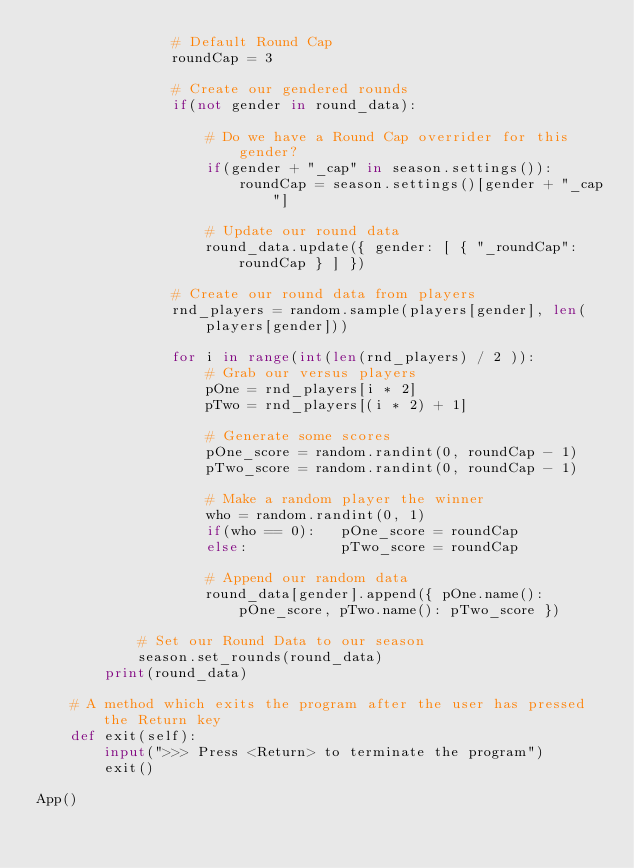<code> <loc_0><loc_0><loc_500><loc_500><_Python_>                # Default Round Cap
                roundCap = 3

                # Create our gendered rounds
                if(not gender in round_data):

                    # Do we have a Round Cap overrider for this gender?
                    if(gender + "_cap" in season.settings()):
                        roundCap = season.settings()[gender + "_cap"]
                    
                    # Update our round data
                    round_data.update({ gender: [ { "_roundCap": roundCap } ] })

                # Create our round data from players
                rnd_players = random.sample(players[gender], len(players[gender]))

                for i in range(int(len(rnd_players) / 2 )):
                    # Grab our versus players
                    pOne = rnd_players[i * 2]
                    pTwo = rnd_players[(i * 2) + 1]

                    # Generate some scores
                    pOne_score = random.randint(0, roundCap - 1)
                    pTwo_score = random.randint(0, roundCap - 1)

                    # Make a random player the winner
                    who = random.randint(0, 1)
                    if(who == 0):   pOne_score = roundCap
                    else:           pTwo_score = roundCap

                    # Append our random data
                    round_data[gender].append({ pOne.name(): pOne_score, pTwo.name(): pTwo_score })
    
            # Set our Round Data to our season
            season.set_rounds(round_data)
        print(round_data)

    # A method which exits the program after the user has pressed the Return key
    def exit(self):
        input(">>> Press <Return> to terminate the program")
        exit()

App()</code> 